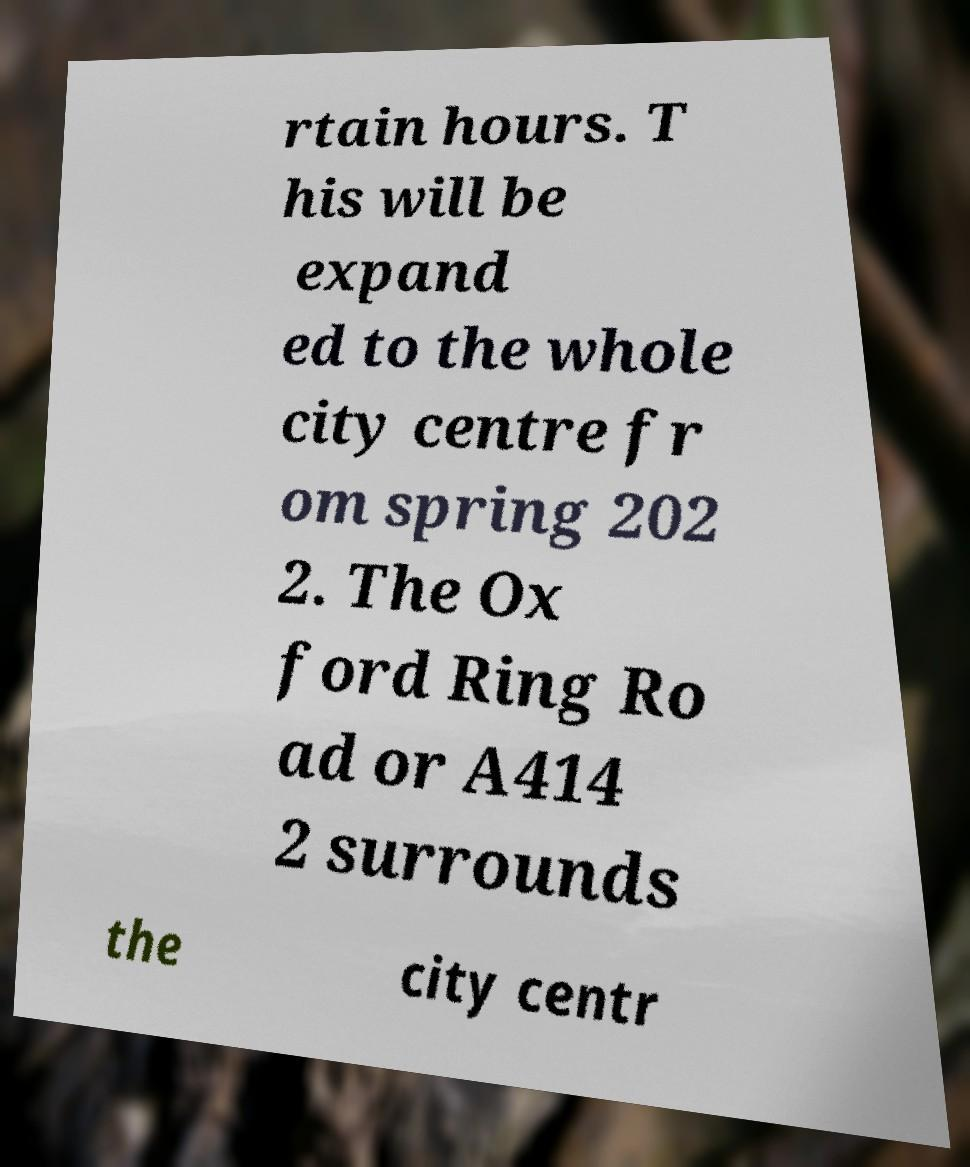Please identify and transcribe the text found in this image. rtain hours. T his will be expand ed to the whole city centre fr om spring 202 2. The Ox ford Ring Ro ad or A414 2 surrounds the city centr 